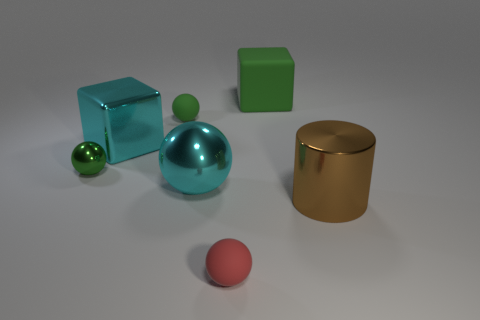There is a matte sphere that is in front of the big brown shiny object that is to the right of the big ball; how many tiny green balls are to the right of it?
Make the answer very short. 0. What number of large cyan cubes are there?
Keep it short and to the point. 1. Is the number of green things that are in front of the tiny green matte sphere less than the number of blocks that are in front of the big metal block?
Offer a terse response. No. Are there fewer brown metal cylinders on the right side of the large metal cylinder than large brown spheres?
Ensure brevity in your answer.  No. There is a object that is behind the tiny rubber thing that is behind the thing in front of the cylinder; what is its material?
Ensure brevity in your answer.  Rubber. What number of things are either metal objects that are on the left side of the small red ball or tiny rubber objects that are in front of the large brown cylinder?
Make the answer very short. 4. What material is the big cyan object that is the same shape as the big green object?
Your answer should be very brief. Metal. Are there the same number of matte cubes and small rubber things?
Keep it short and to the point. No. What number of shiny things are green cylinders or tiny objects?
Provide a succinct answer. 1. There is a small thing that is the same material as the large brown cylinder; what is its shape?
Your answer should be very brief. Sphere. 